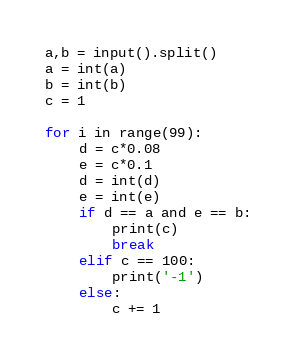Convert code to text. <code><loc_0><loc_0><loc_500><loc_500><_Python_>a,b = input().split()
a = int(a)
b = int(b)
c = 1

for i in range(99):
    d = c*0.08
    e = c*0.1
    d = int(d)
    e = int(e)
    if d == a and e == b:
        print(c)
        break
    elif c == 100:
        print('-1')
    else:
        c += 1</code> 